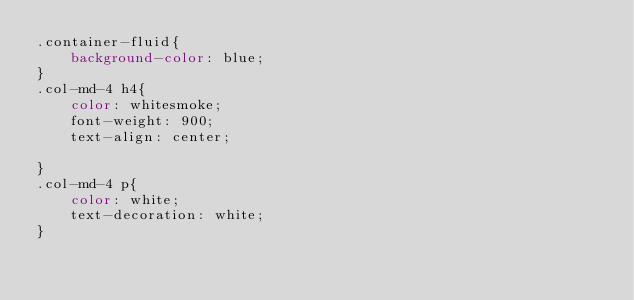Convert code to text. <code><loc_0><loc_0><loc_500><loc_500><_CSS_>.container-fluid{
    background-color: blue;
}
.col-md-4 h4{
    color: whitesmoke;
    font-weight: 900;
    text-align: center;
   
}
.col-md-4 p{
    color: white;
    text-decoration: white;
}</code> 